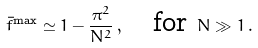Convert formula to latex. <formula><loc_0><loc_0><loc_500><loc_500>\bar { f } ^ { \max } \simeq 1 - \frac { \pi ^ { 2 } } { N ^ { 2 } } \, , \quad \text {for} \ N \gg 1 \, .</formula> 